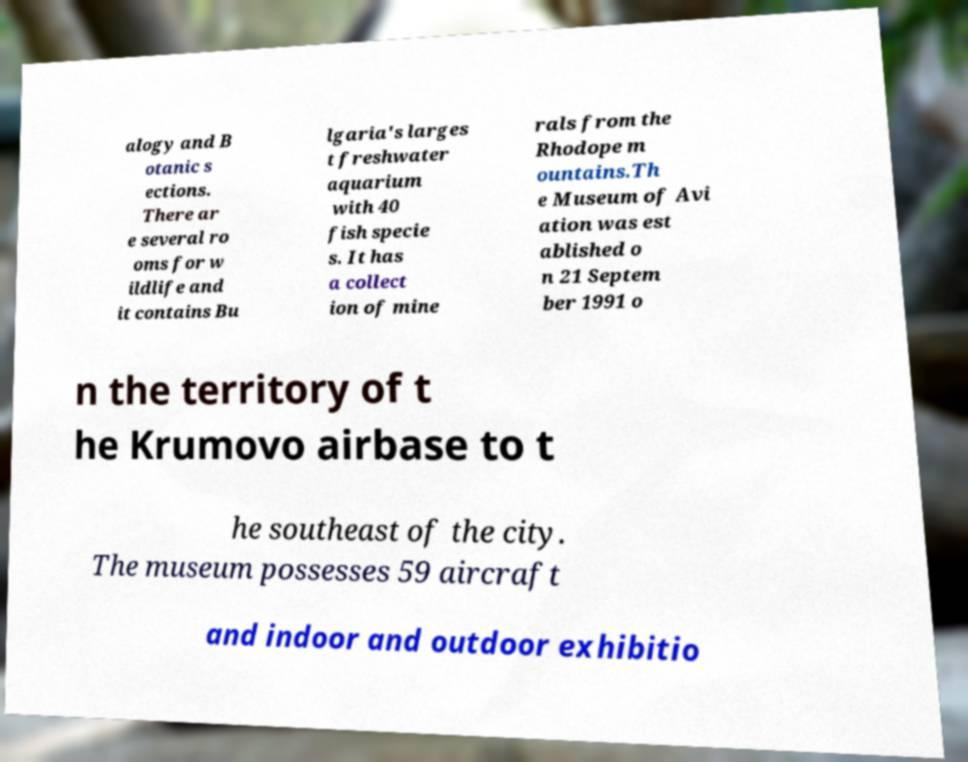For documentation purposes, I need the text within this image transcribed. Could you provide that? alogy and B otanic s ections. There ar e several ro oms for w ildlife and it contains Bu lgaria's larges t freshwater aquarium with 40 fish specie s. It has a collect ion of mine rals from the Rhodope m ountains.Th e Museum of Avi ation was est ablished o n 21 Septem ber 1991 o n the territory of t he Krumovo airbase to t he southeast of the city. The museum possesses 59 aircraft and indoor and outdoor exhibitio 